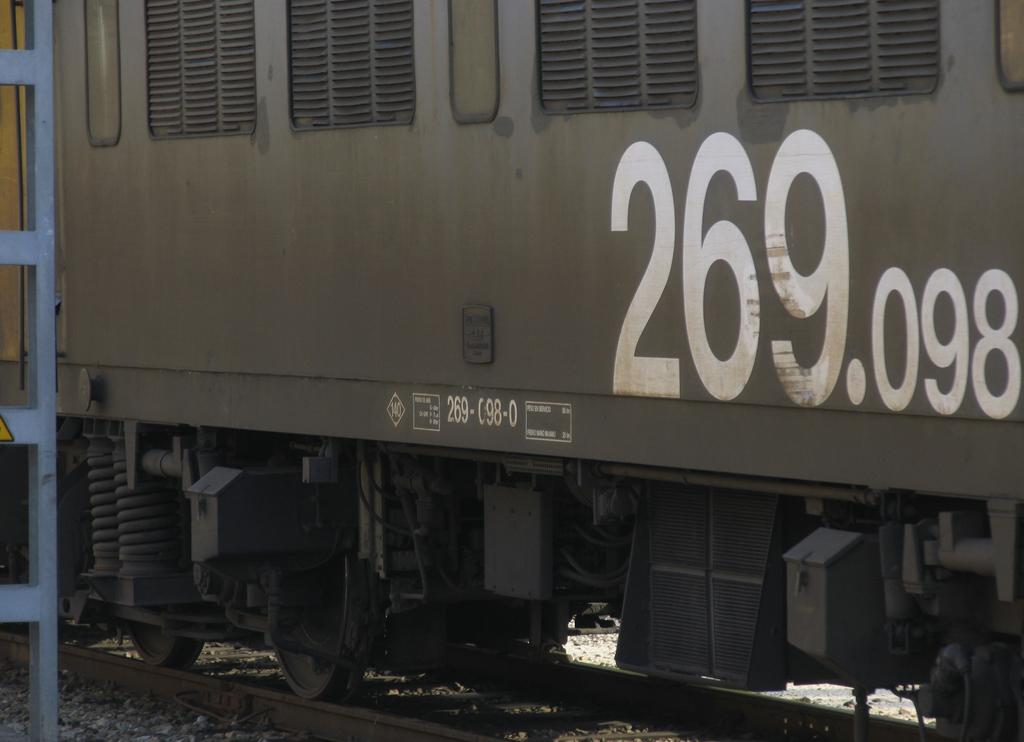What is the main subject of the image? The main subject of the image is a train. Where is the train located in the image? The train is on a train track. What can be seen on the train? There is text written on the train. What is visible in the background of the image? There is a pole visible in the background of the image. What type of heat source is present on the train in the image? There is no heat source visible on the train in the image. What religious belief is represented by the text on the train? The text on the train does not represent any religious belief; it is likely a train identification or company name. 